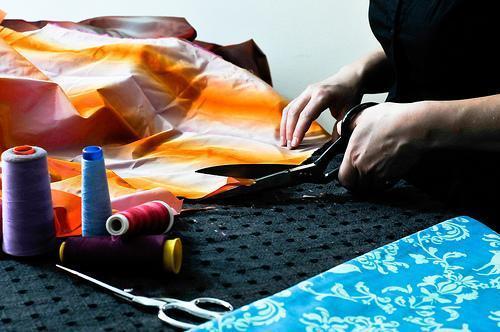How many pairs of scissors are there?
Give a very brief answer. 2. How many spools of thread are there?
Give a very brief answer. 4. 